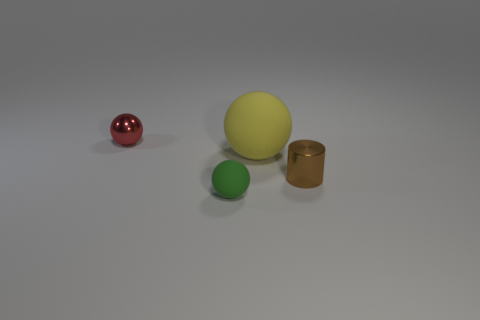Subtract all large yellow balls. How many balls are left? 2 Add 2 small red spheres. How many objects exist? 6 Subtract all cylinders. How many objects are left? 3 Subtract all blue balls. Subtract all yellow cylinders. How many balls are left? 3 Subtract all small matte things. Subtract all matte things. How many objects are left? 1 Add 1 green objects. How many green objects are left? 2 Add 2 green matte objects. How many green matte objects exist? 3 Subtract 0 gray cubes. How many objects are left? 4 